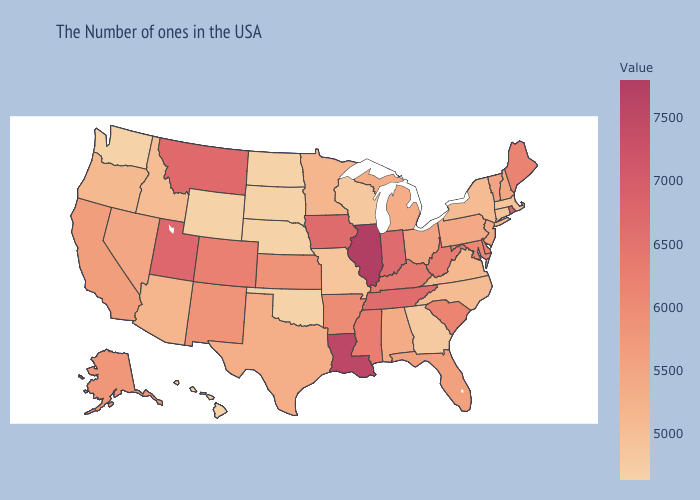Among the states that border Nebraska , which have the highest value?
Concise answer only. Iowa. Among the states that border Utah , which have the lowest value?
Keep it brief. Wyoming. Which states have the lowest value in the USA?
Be succinct. Nebraska, Oklahoma, South Dakota, North Dakota, Wyoming, Washington, Hawaii. Does Connecticut have the highest value in the Northeast?
Give a very brief answer. No. 